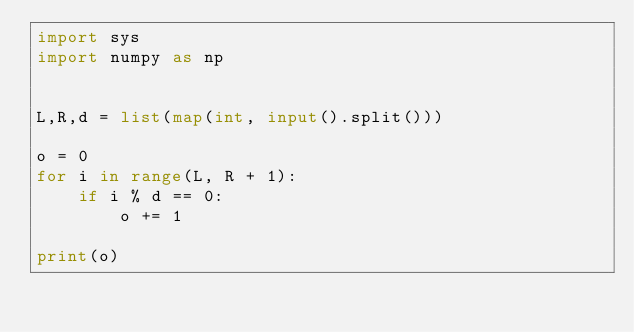Convert code to text. <code><loc_0><loc_0><loc_500><loc_500><_Python_>import sys
import numpy as np


L,R,d = list(map(int, input().split()))

o = 0
for i in range(L, R + 1):
    if i % d == 0:
        o += 1

print(o)

</code> 